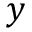<formula> <loc_0><loc_0><loc_500><loc_500>y</formula> 